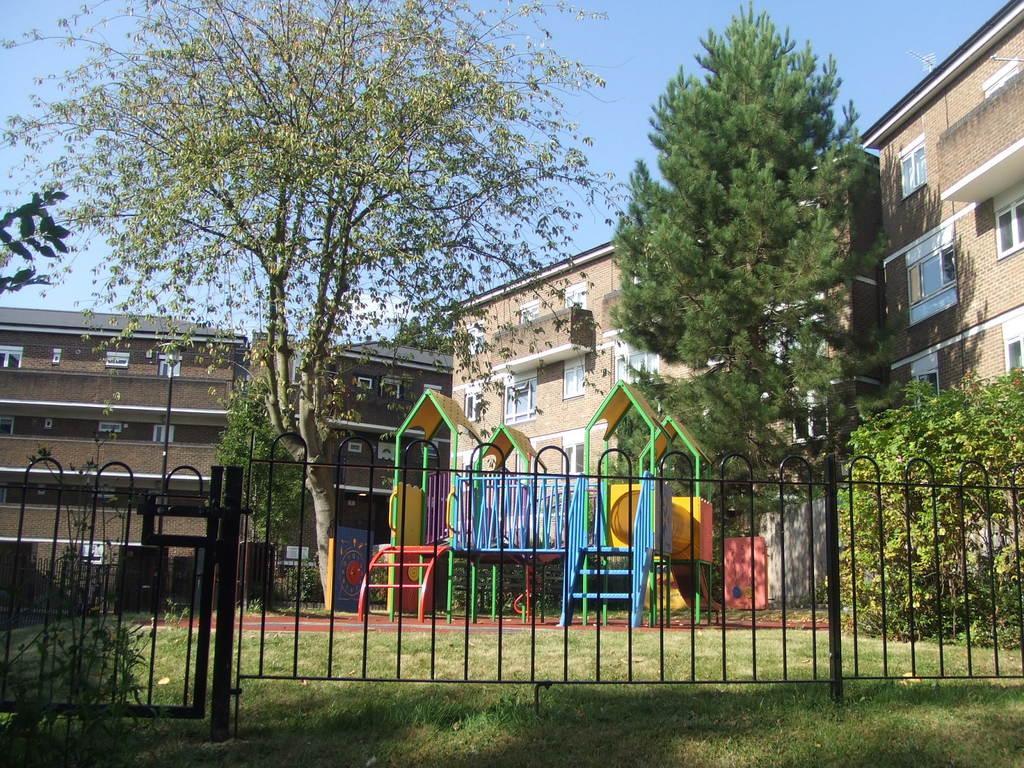Please provide a concise description of this image. In this image sky truncated towards the top of the image, there are buildings, there is a building truncated towards the right of the image, there is a building truncated towards the left of the image, there are trees, there is a tree truncated towards the top of the image, there is a tree truncated towards the left of the image, there is a tree truncated towards the right of the image, there is a fencing truncated, there are plants, there is grass truncated towards the bottom of the image, there are objects on the ground. 